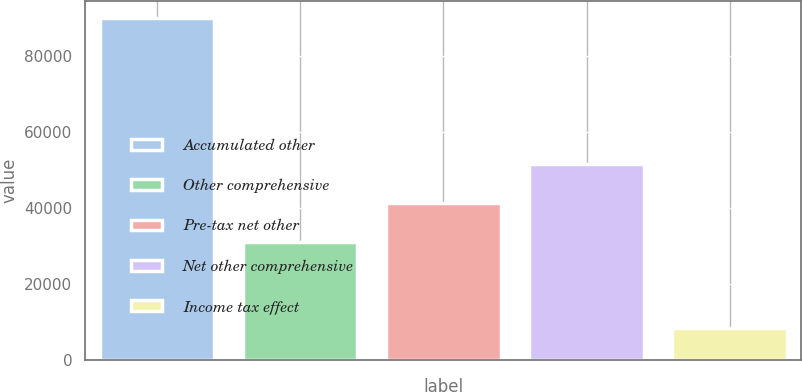<chart> <loc_0><loc_0><loc_500><loc_500><bar_chart><fcel>Accumulated other<fcel>Other comprehensive<fcel>Pre-tax net other<fcel>Net other comprehensive<fcel>Income tax effect<nl><fcel>89924.4<fcel>31086<fcel>41333.4<fcel>51580.8<fcel>8289<nl></chart> 